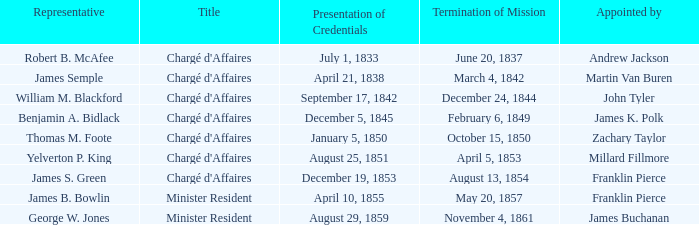What is the mission termination mentioned with a presentation of credentials on august 29, 1859? November 4, 1861. 